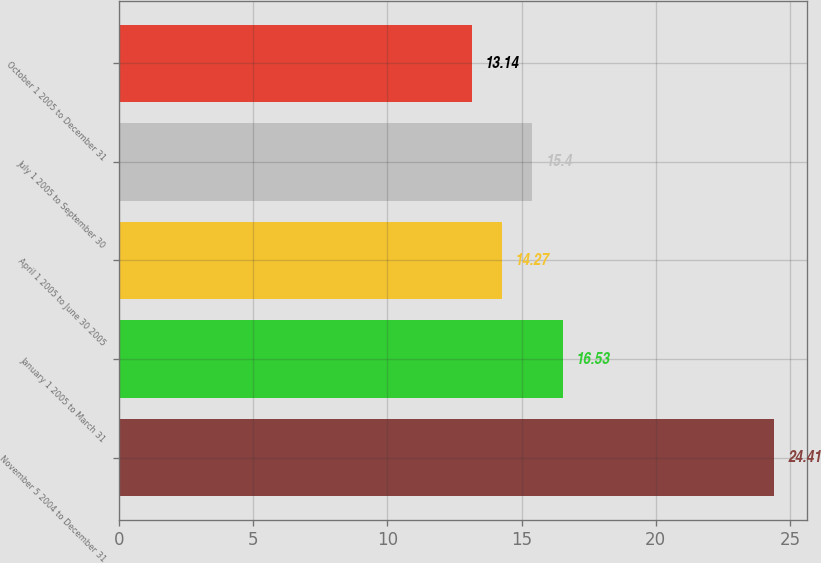<chart> <loc_0><loc_0><loc_500><loc_500><bar_chart><fcel>November 5 2004 to December 31<fcel>January 1 2005 to March 31<fcel>April 1 2005 to June 30 2005<fcel>July 1 2005 to September 30<fcel>October 1 2005 to December 31<nl><fcel>24.41<fcel>16.53<fcel>14.27<fcel>15.4<fcel>13.14<nl></chart> 